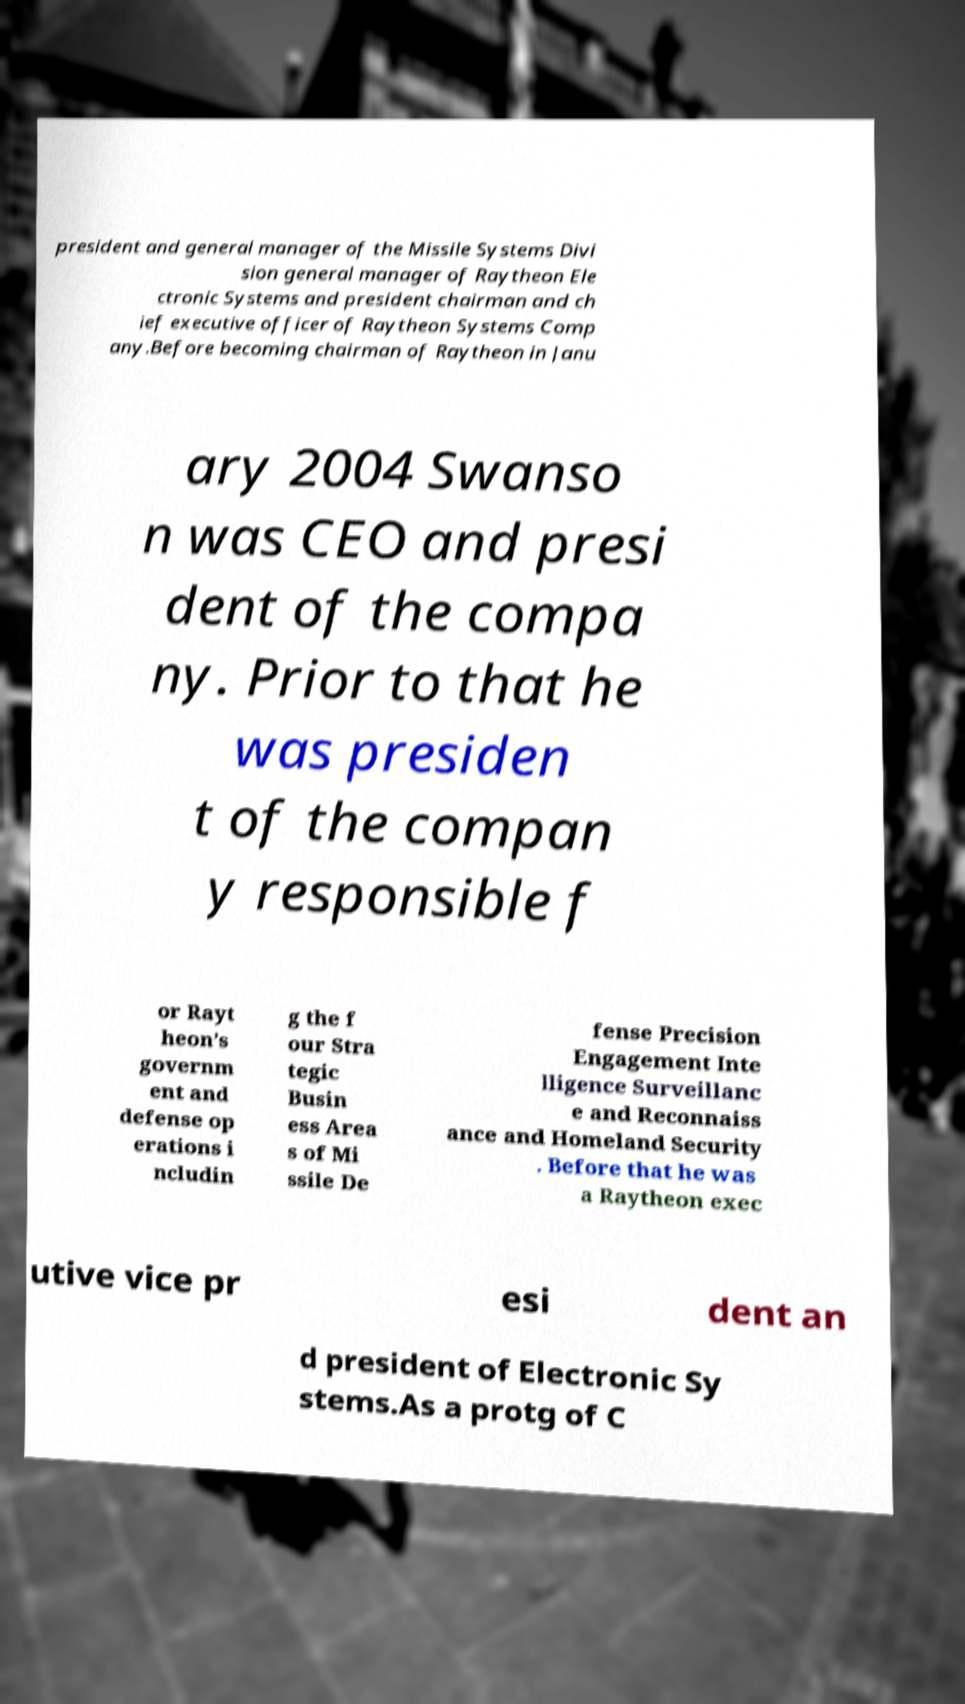There's text embedded in this image that I need extracted. Can you transcribe it verbatim? president and general manager of the Missile Systems Divi sion general manager of Raytheon Ele ctronic Systems and president chairman and ch ief executive officer of Raytheon Systems Comp any.Before becoming chairman of Raytheon in Janu ary 2004 Swanso n was CEO and presi dent of the compa ny. Prior to that he was presiden t of the compan y responsible f or Rayt heon’s governm ent and defense op erations i ncludin g the f our Stra tegic Busin ess Area s of Mi ssile De fense Precision Engagement Inte lligence Surveillanc e and Reconnaiss ance and Homeland Security . Before that he was a Raytheon exec utive vice pr esi dent an d president of Electronic Sy stems.As a protg of C 